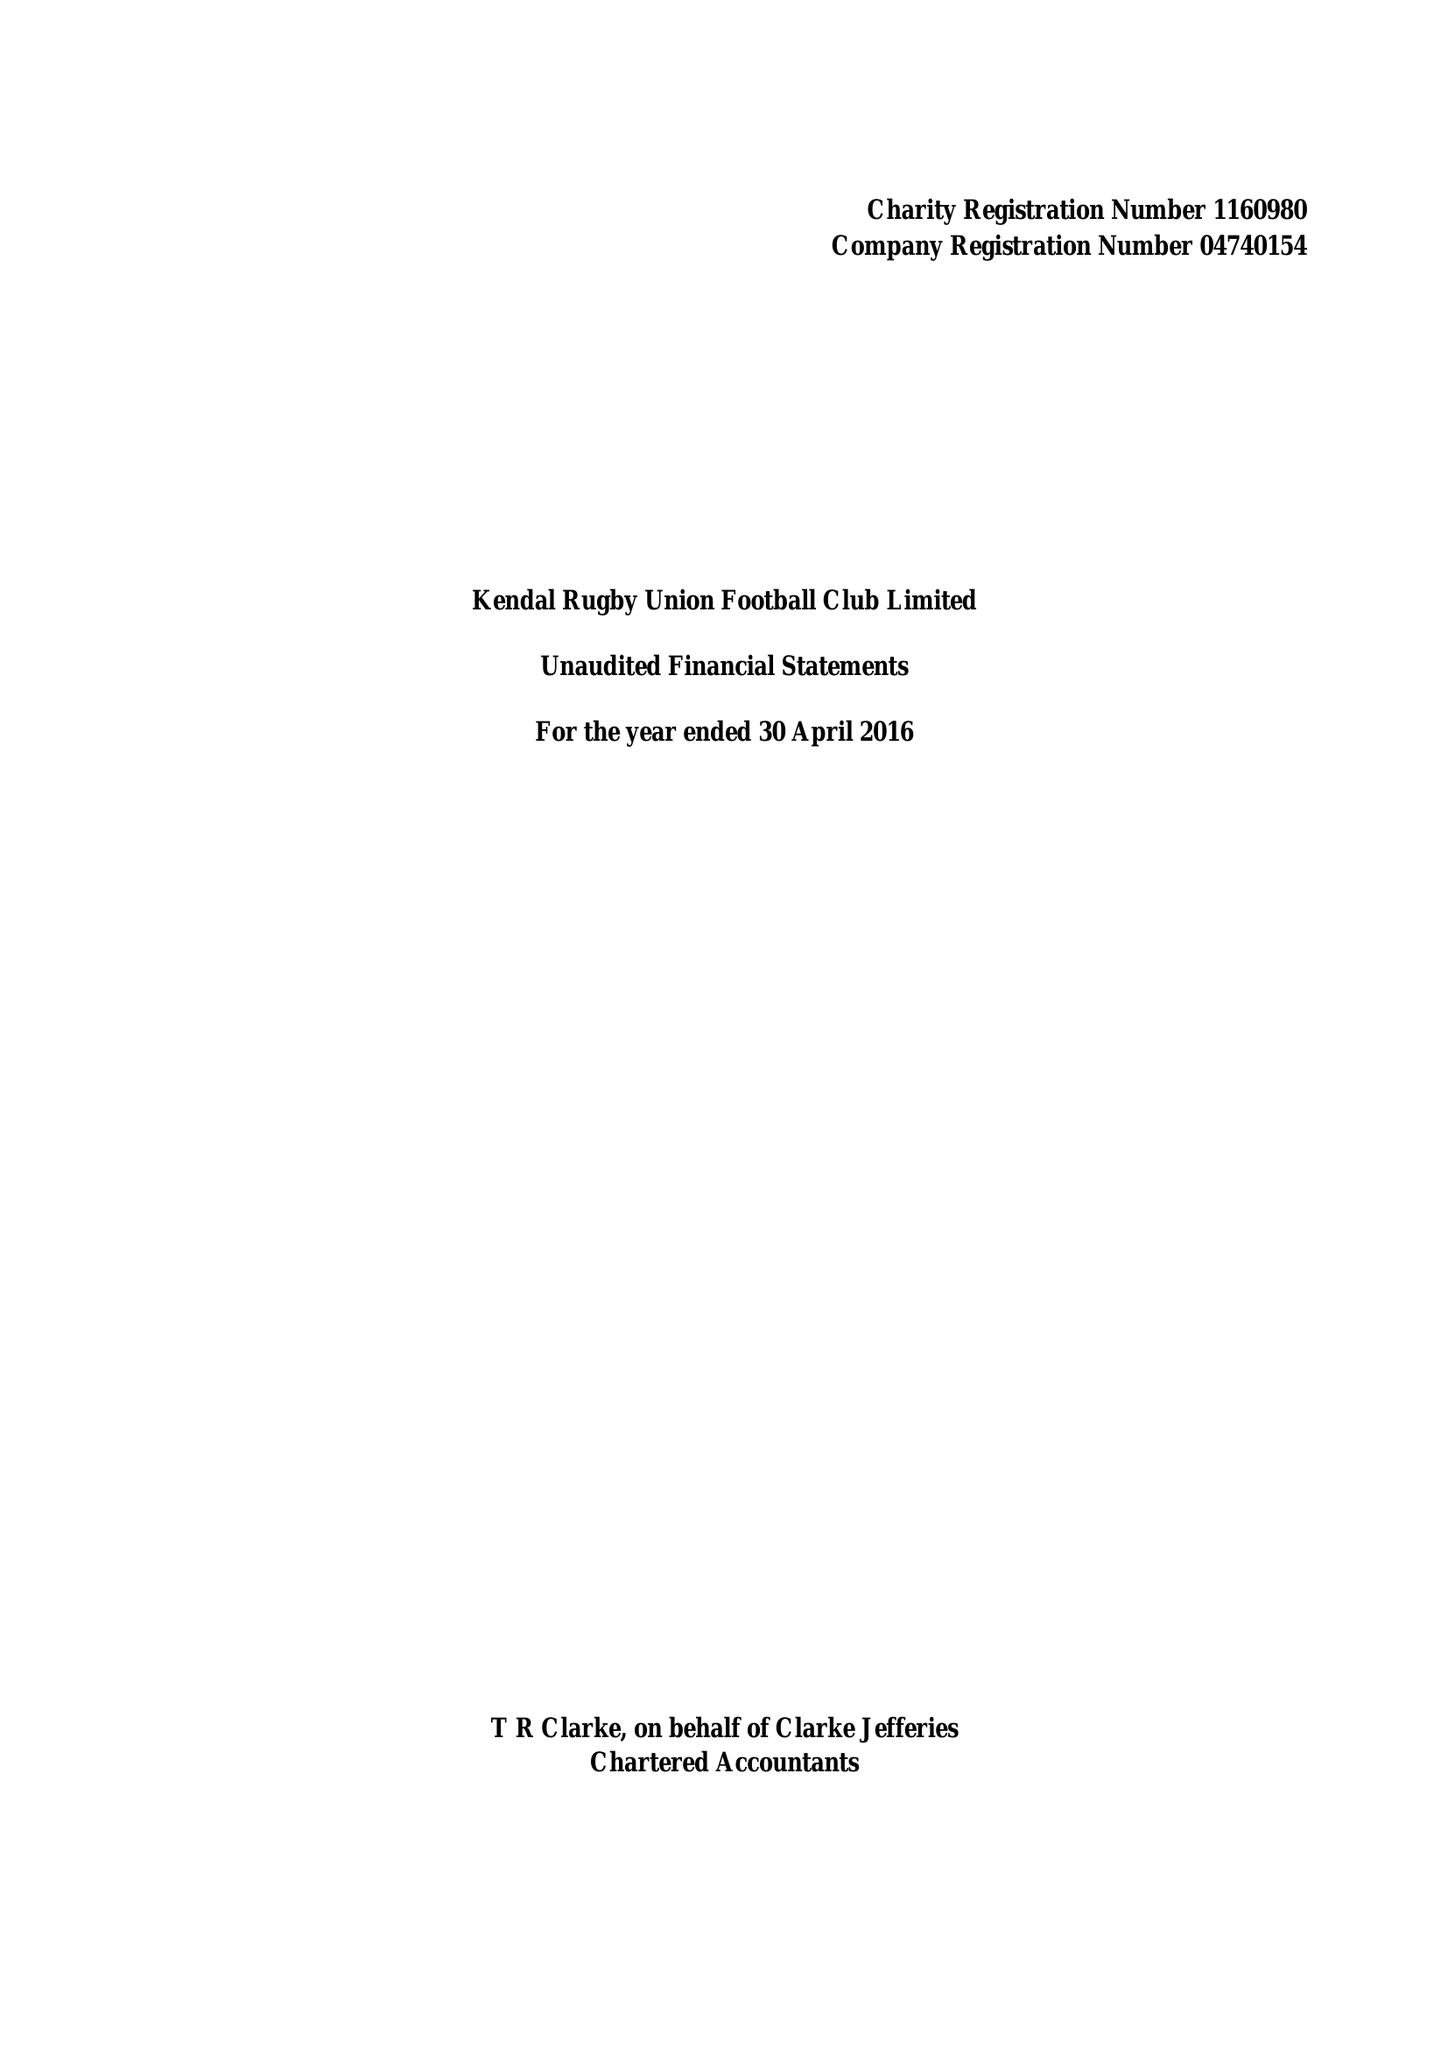What is the value for the spending_annually_in_british_pounds?
Answer the question using a single word or phrase. 103515.00 